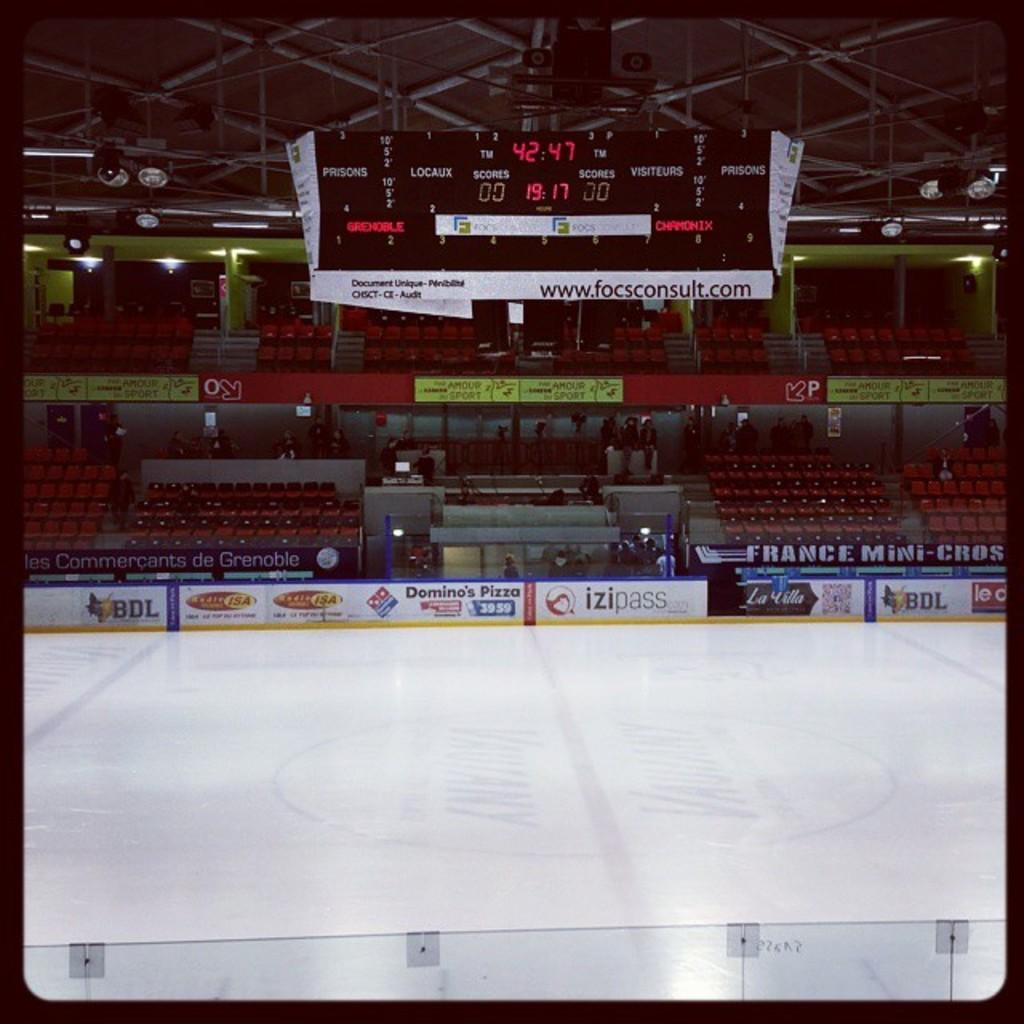<image>
Relay a brief, clear account of the picture shown. The time shown on the scoreboard is 19.17. 